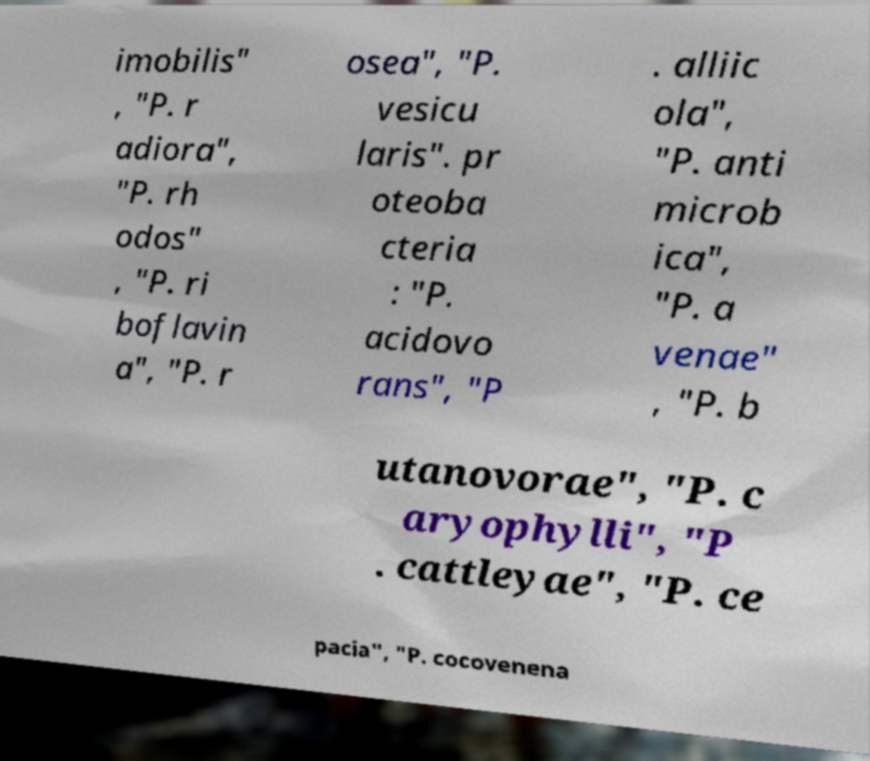Please read and relay the text visible in this image. What does it say? imobilis" , "P. r adiora", "P. rh odos" , "P. ri boflavin a", "P. r osea", "P. vesicu laris". pr oteoba cteria : "P. acidovo rans", "P . alliic ola", "P. anti microb ica", "P. a venae" , "P. b utanovorae", "P. c aryophylli", "P . cattleyae", "P. ce pacia", "P. cocovenena 